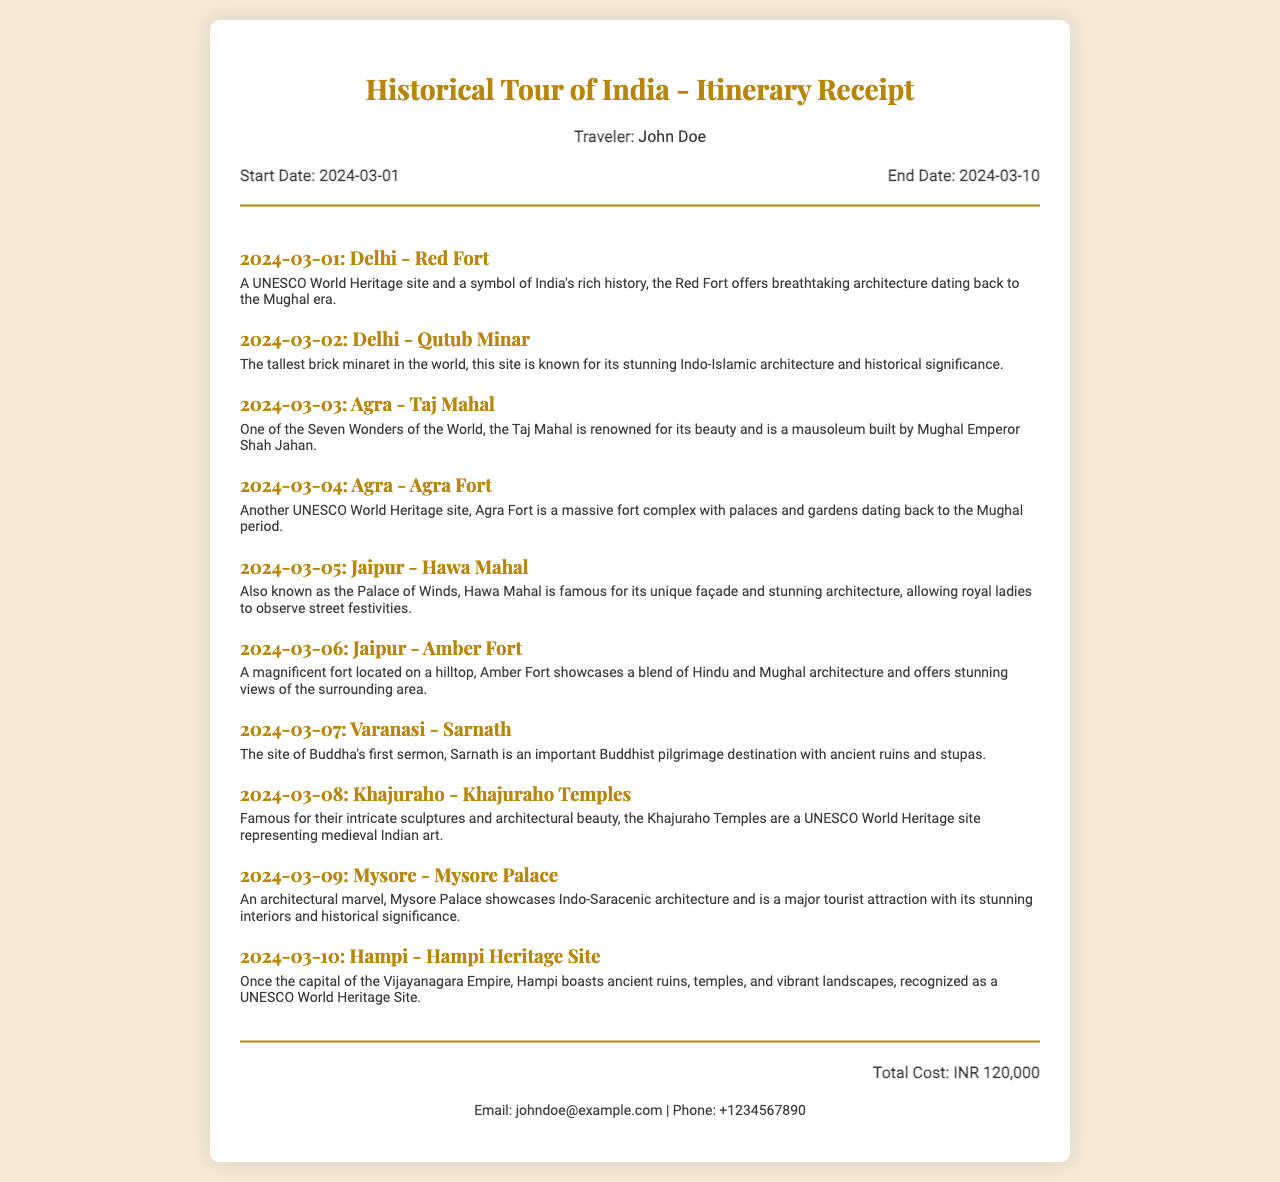What is the traveler's name? The traveler's name is mentioned in the document under traveler info.
Answer: John Doe What is the start date of the trip? The start date can be found in the trip dates section of the document.
Answer: 2024-03-01 How many days is the trip planned for? The trip's duration is inferred from the start and end dates provided in the document.
Answer: 10 days Which UNESCO World Heritage site is visited on March 3? The itinerary outlines specific sites associated with the dates, including UNESCO locations.
Answer: Taj Mahal What is the total cost of the tour? The total cost is listed at the bottom of the document.
Answer: INR 120,000 Which city has the Amber Fort? The itinerary indicates the specific cities associated with each site.
Answer: Jaipur What event is associated with Sarnath? The explanation provided with Sarnath mentions an important historical event.
Answer: Buddha's first sermon What type of architectural style is showcased at Mysore Palace? The document includes a description of the architectural features of Mysore Palace.
Answer: Indo-Saracenic Where can the contact information be found? The contact information is provided at the end of the document.
Answer: At the bottom of the receipt 